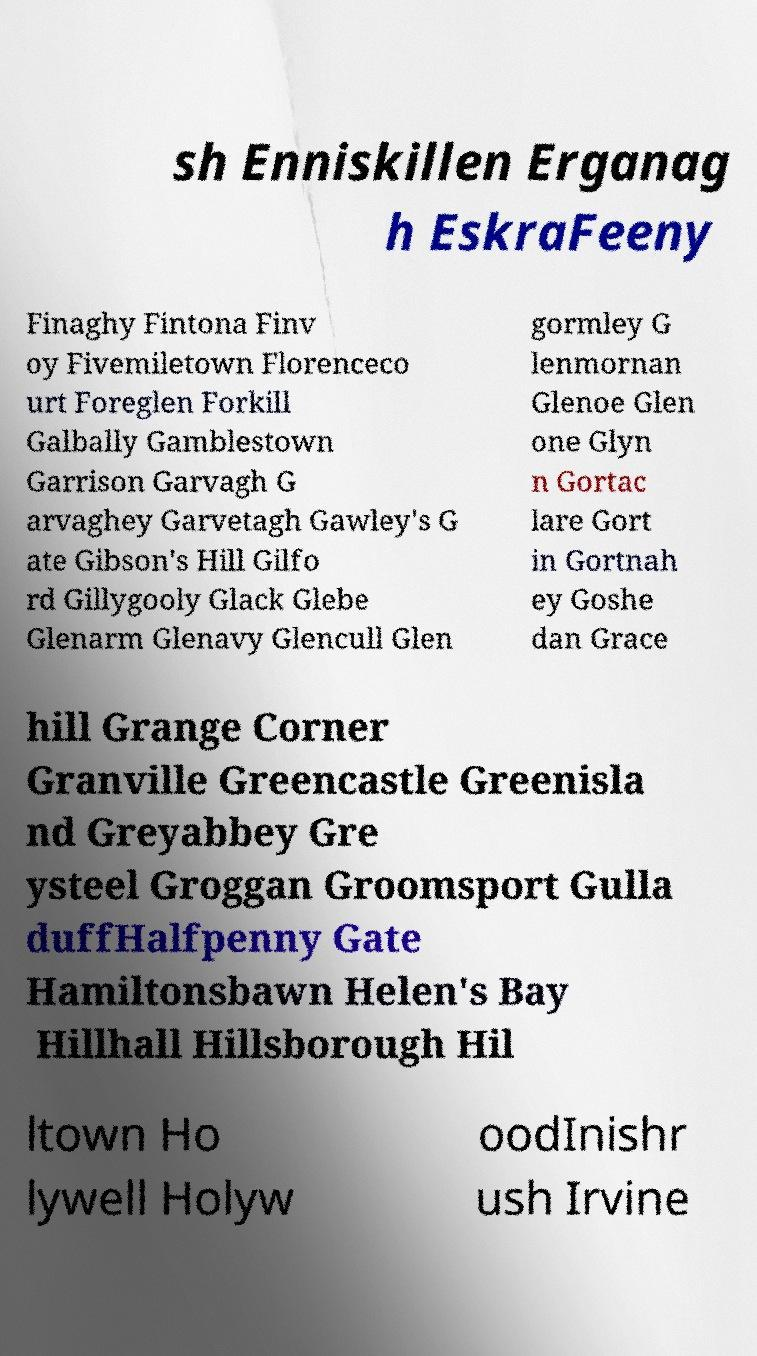Please read and relay the text visible in this image. What does it say? sh Enniskillen Erganag h EskraFeeny Finaghy Fintona Finv oy Fivemiletown Florenceco urt Foreglen Forkill Galbally Gamblestown Garrison Garvagh G arvaghey Garvetagh Gawley's G ate Gibson's Hill Gilfo rd Gillygooly Glack Glebe Glenarm Glenavy Glencull Glen gormley G lenmornan Glenoe Glen one Glyn n Gortac lare Gort in Gortnah ey Goshe dan Grace hill Grange Corner Granville Greencastle Greenisla nd Greyabbey Gre ysteel Groggan Groomsport Gulla duffHalfpenny Gate Hamiltonsbawn Helen's Bay Hillhall Hillsborough Hil ltown Ho lywell Holyw oodInishr ush Irvine 